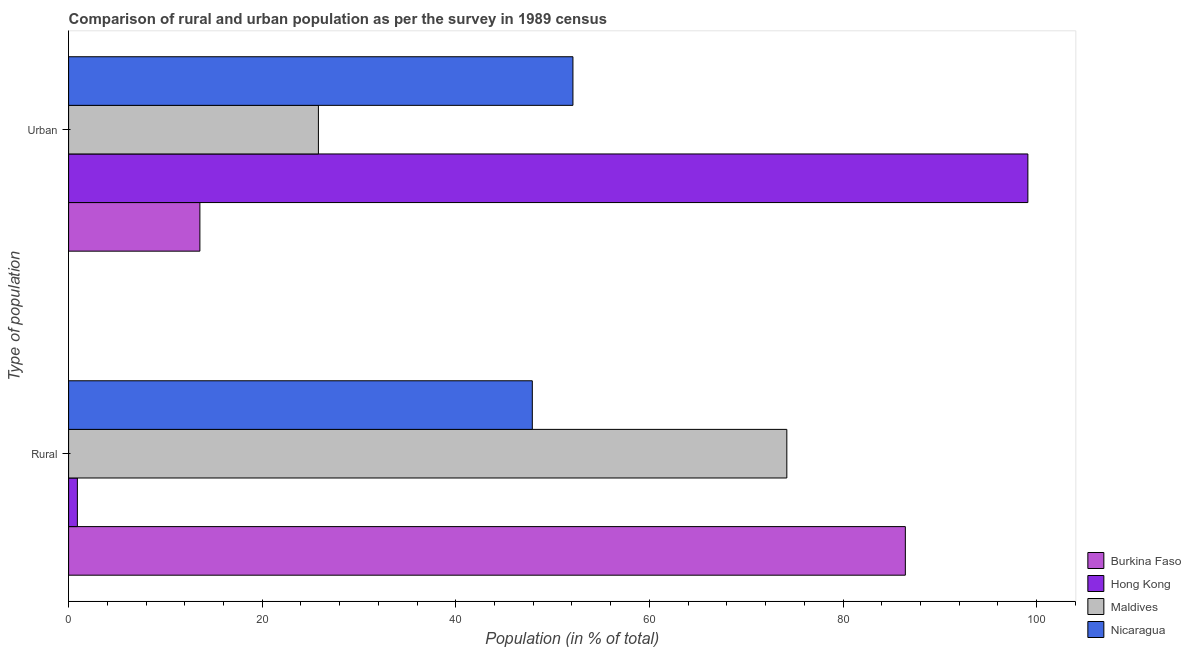How many different coloured bars are there?
Offer a very short reply. 4. How many groups of bars are there?
Your answer should be very brief. 2. Are the number of bars per tick equal to the number of legend labels?
Offer a terse response. Yes. Are the number of bars on each tick of the Y-axis equal?
Your response must be concise. Yes. What is the label of the 1st group of bars from the top?
Your answer should be very brief. Urban. What is the urban population in Hong Kong?
Offer a terse response. 99.09. Across all countries, what is the maximum rural population?
Ensure brevity in your answer.  86.44. Across all countries, what is the minimum urban population?
Give a very brief answer. 13.56. In which country was the urban population maximum?
Ensure brevity in your answer.  Hong Kong. In which country was the urban population minimum?
Make the answer very short. Burkina Faso. What is the total rural population in the graph?
Provide a succinct answer. 209.44. What is the difference between the urban population in Hong Kong and that in Nicaragua?
Your response must be concise. 47. What is the difference between the urban population in Hong Kong and the rural population in Nicaragua?
Your response must be concise. 51.19. What is the average urban population per country?
Give a very brief answer. 47.64. What is the difference between the rural population and urban population in Maldives?
Your response must be concise. 48.39. What is the ratio of the urban population in Burkina Faso to that in Hong Kong?
Give a very brief answer. 0.14. Is the rural population in Nicaragua less than that in Hong Kong?
Give a very brief answer. No. In how many countries, is the rural population greater than the average rural population taken over all countries?
Keep it short and to the point. 2. What does the 1st bar from the top in Urban represents?
Provide a short and direct response. Nicaragua. What does the 1st bar from the bottom in Rural represents?
Give a very brief answer. Burkina Faso. How many countries are there in the graph?
Keep it short and to the point. 4. What is the difference between two consecutive major ticks on the X-axis?
Provide a short and direct response. 20. Are the values on the major ticks of X-axis written in scientific E-notation?
Ensure brevity in your answer.  No. Where does the legend appear in the graph?
Keep it short and to the point. Bottom right. How are the legend labels stacked?
Offer a very short reply. Vertical. What is the title of the graph?
Your answer should be compact. Comparison of rural and urban population as per the survey in 1989 census. What is the label or title of the X-axis?
Offer a very short reply. Population (in % of total). What is the label or title of the Y-axis?
Ensure brevity in your answer.  Type of population. What is the Population (in % of total) in Burkina Faso in Rural?
Provide a succinct answer. 86.44. What is the Population (in % of total) of Hong Kong in Rural?
Provide a succinct answer. 0.91. What is the Population (in % of total) in Maldives in Rural?
Give a very brief answer. 74.19. What is the Population (in % of total) of Nicaragua in Rural?
Your response must be concise. 47.9. What is the Population (in % of total) in Burkina Faso in Urban?
Provide a short and direct response. 13.56. What is the Population (in % of total) in Hong Kong in Urban?
Give a very brief answer. 99.09. What is the Population (in % of total) in Maldives in Urban?
Offer a terse response. 25.81. What is the Population (in % of total) of Nicaragua in Urban?
Provide a succinct answer. 52.1. Across all Type of population, what is the maximum Population (in % of total) of Burkina Faso?
Your answer should be compact. 86.44. Across all Type of population, what is the maximum Population (in % of total) of Hong Kong?
Your answer should be very brief. 99.09. Across all Type of population, what is the maximum Population (in % of total) of Maldives?
Keep it short and to the point. 74.19. Across all Type of population, what is the maximum Population (in % of total) of Nicaragua?
Ensure brevity in your answer.  52.1. Across all Type of population, what is the minimum Population (in % of total) in Burkina Faso?
Give a very brief answer. 13.56. Across all Type of population, what is the minimum Population (in % of total) in Hong Kong?
Provide a short and direct response. 0.91. Across all Type of population, what is the minimum Population (in % of total) in Maldives?
Make the answer very short. 25.81. Across all Type of population, what is the minimum Population (in % of total) in Nicaragua?
Offer a terse response. 47.9. What is the total Population (in % of total) in Nicaragua in the graph?
Offer a terse response. 100. What is the difference between the Population (in % of total) of Burkina Faso in Rural and that in Urban?
Ensure brevity in your answer.  72.87. What is the difference between the Population (in % of total) in Hong Kong in Rural and that in Urban?
Give a very brief answer. -98.19. What is the difference between the Population (in % of total) of Maldives in Rural and that in Urban?
Ensure brevity in your answer.  48.39. What is the difference between the Population (in % of total) in Nicaragua in Rural and that in Urban?
Give a very brief answer. -4.2. What is the difference between the Population (in % of total) in Burkina Faso in Rural and the Population (in % of total) in Hong Kong in Urban?
Your answer should be very brief. -12.66. What is the difference between the Population (in % of total) of Burkina Faso in Rural and the Population (in % of total) of Maldives in Urban?
Ensure brevity in your answer.  60.63. What is the difference between the Population (in % of total) in Burkina Faso in Rural and the Population (in % of total) in Nicaragua in Urban?
Provide a short and direct response. 34.34. What is the difference between the Population (in % of total) of Hong Kong in Rural and the Population (in % of total) of Maldives in Urban?
Ensure brevity in your answer.  -24.9. What is the difference between the Population (in % of total) of Hong Kong in Rural and the Population (in % of total) of Nicaragua in Urban?
Provide a succinct answer. -51.19. What is the difference between the Population (in % of total) in Maldives in Rural and the Population (in % of total) in Nicaragua in Urban?
Your answer should be very brief. 22.1. What is the average Population (in % of total) in Hong Kong per Type of population?
Make the answer very short. 50. What is the average Population (in % of total) of Maldives per Type of population?
Offer a terse response. 50. What is the difference between the Population (in % of total) in Burkina Faso and Population (in % of total) in Hong Kong in Rural?
Give a very brief answer. 85.53. What is the difference between the Population (in % of total) of Burkina Faso and Population (in % of total) of Maldives in Rural?
Your answer should be compact. 12.24. What is the difference between the Population (in % of total) in Burkina Faso and Population (in % of total) in Nicaragua in Rural?
Keep it short and to the point. 38.53. What is the difference between the Population (in % of total) in Hong Kong and Population (in % of total) in Maldives in Rural?
Your answer should be compact. -73.29. What is the difference between the Population (in % of total) in Hong Kong and Population (in % of total) in Nicaragua in Rural?
Give a very brief answer. -47. What is the difference between the Population (in % of total) in Maldives and Population (in % of total) in Nicaragua in Rural?
Provide a succinct answer. 26.29. What is the difference between the Population (in % of total) of Burkina Faso and Population (in % of total) of Hong Kong in Urban?
Make the answer very short. -85.53. What is the difference between the Population (in % of total) of Burkina Faso and Population (in % of total) of Maldives in Urban?
Provide a succinct answer. -12.24. What is the difference between the Population (in % of total) in Burkina Faso and Population (in % of total) in Nicaragua in Urban?
Your answer should be very brief. -38.53. What is the difference between the Population (in % of total) of Hong Kong and Population (in % of total) of Maldives in Urban?
Ensure brevity in your answer.  73.29. What is the difference between the Population (in % of total) of Hong Kong and Population (in % of total) of Nicaragua in Urban?
Your answer should be compact. 47. What is the difference between the Population (in % of total) in Maldives and Population (in % of total) in Nicaragua in Urban?
Your answer should be compact. -26.29. What is the ratio of the Population (in % of total) in Burkina Faso in Rural to that in Urban?
Provide a succinct answer. 6.37. What is the ratio of the Population (in % of total) in Hong Kong in Rural to that in Urban?
Your answer should be very brief. 0.01. What is the ratio of the Population (in % of total) in Maldives in Rural to that in Urban?
Give a very brief answer. 2.88. What is the ratio of the Population (in % of total) in Nicaragua in Rural to that in Urban?
Ensure brevity in your answer.  0.92. What is the difference between the highest and the second highest Population (in % of total) of Burkina Faso?
Offer a very short reply. 72.87. What is the difference between the highest and the second highest Population (in % of total) in Hong Kong?
Offer a very short reply. 98.19. What is the difference between the highest and the second highest Population (in % of total) in Maldives?
Offer a terse response. 48.39. What is the difference between the highest and the second highest Population (in % of total) of Nicaragua?
Ensure brevity in your answer.  4.2. What is the difference between the highest and the lowest Population (in % of total) of Burkina Faso?
Make the answer very short. 72.87. What is the difference between the highest and the lowest Population (in % of total) in Hong Kong?
Your response must be concise. 98.19. What is the difference between the highest and the lowest Population (in % of total) of Maldives?
Offer a terse response. 48.39. What is the difference between the highest and the lowest Population (in % of total) of Nicaragua?
Your answer should be very brief. 4.2. 